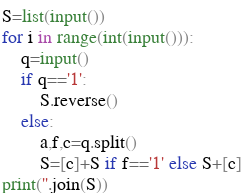Convert code to text. <code><loc_0><loc_0><loc_500><loc_500><_Python_>S=list(input())
for i in range(int(input())):
    q=input()
    if q=='1':
        S.reverse()
    else:
        a,f,c=q.split()
        S=[c]+S if f=='1' else S+[c] 
print(''.join(S))</code> 